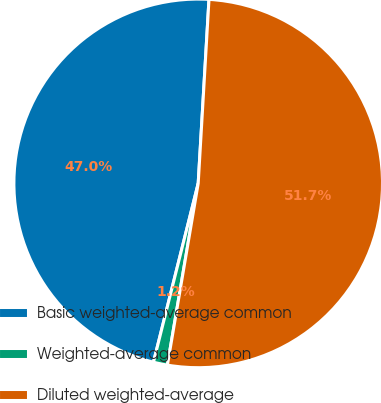Convert chart. <chart><loc_0><loc_0><loc_500><loc_500><pie_chart><fcel>Basic weighted-average common<fcel>Weighted-average common<fcel>Diluted weighted-average<nl><fcel>47.03%<fcel>1.23%<fcel>51.74%<nl></chart> 